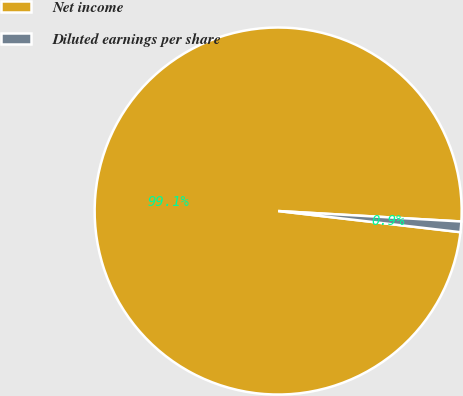Convert chart. <chart><loc_0><loc_0><loc_500><loc_500><pie_chart><fcel>Net income<fcel>Diluted earnings per share<nl><fcel>99.07%<fcel>0.93%<nl></chart> 